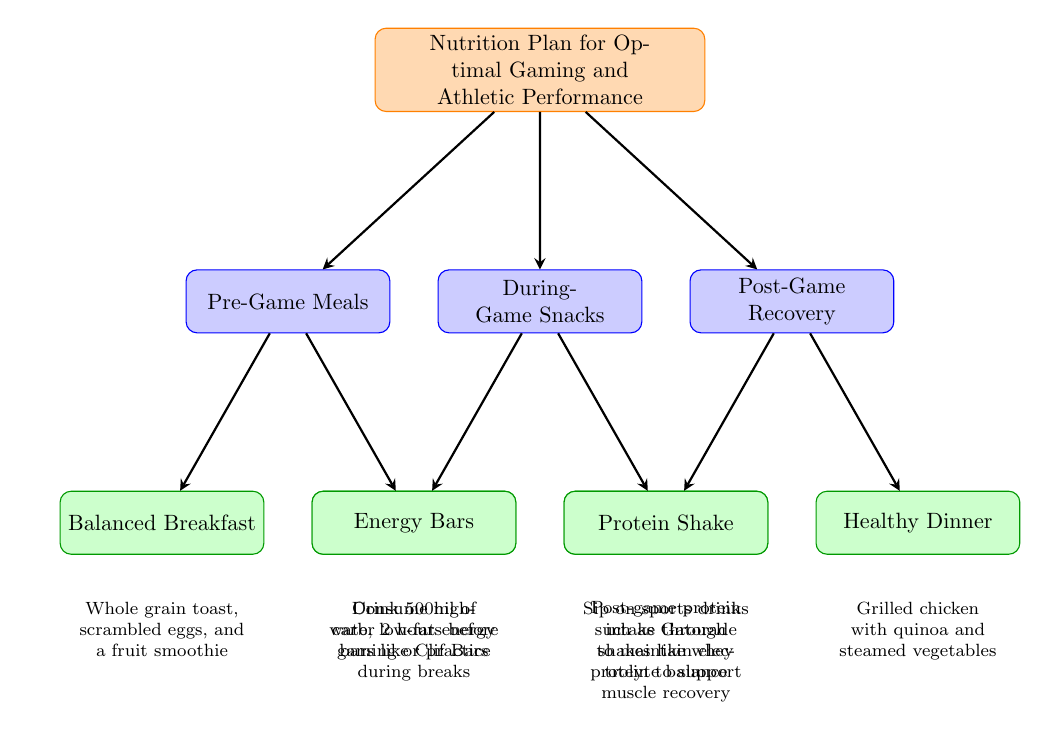What is the root node of the diagram? The root node identifies the main topic of the flow chart, which is "Nutrition Plan for Optimal Gaming and Athletic Performance." It is the starting point of the flow and contains all the categories below it.
Answer: Nutrition Plan for Optimal Gaming and Athletic Performance How many categories are there in the diagram? The diagram contains three categories underneath the root node: "Pre-Game Meals," "During-Game Snacks," and "Post-Game Recovery." Counting these gives us the total.
Answer: 3 What task is associated with Pre-Game Meals? Pre-Game Meals has two tasks listed below it: "Balanced Breakfast" and "Pre-Game Hydration." The question expects to know one of the tasks, and either can be mentioned.
Answer: Balanced Breakfast What type of snacks are recommended during the game? The category "During-Game Snacks" suggests two specific snacks: "Energy Bars" and "Electrolyte Drinks." Both are suitable choices for consumption during breaks.
Answer: Energy Bars What is recommended for post-game protein intake? In the Post-Game Recovery category, "Protein Shake" is mentioned as a task for post-game protein intake to support muscle recovery.
Answer: Protein Shake Which meal includes grilled chicken? The task "Healthy Dinner" in the Post-Game Recovery category specifies a meal with grilled chicken, quinoa, and steamed vegetables as part of the recovery plan.
Answer: Healthy Dinner What should you drink 2 hours before gaming or practice? The "Pre-Game Hydration" task outlines that one should drink 500ml of water two hours prior to the activity, which is crucial for hydration.
Answer: 500ml of water What type of drinks help maintain electrolyte balance during the game? The "Electrolyte Drinks" task indicates that sipping on sports drinks such as Gatorade is recommended to help maintain electrolyte balance while gaming.
Answer: Sports drinks How many tasks are listed under Post-Game Recovery? The Post-Game Recovery category lists two tasks: "Protein Shake" and "Healthy Dinner." Thus, we can count these to find the total number of tasks in that category.
Answer: 2 